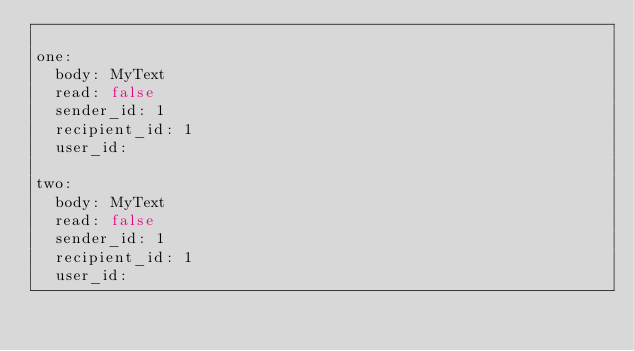Convert code to text. <code><loc_0><loc_0><loc_500><loc_500><_YAML_>
one:
  body: MyText
  read: false
  sender_id: 1
  recipient_id: 1
  user_id: 

two:
  body: MyText
  read: false
  sender_id: 1
  recipient_id: 1
  user_id: 
</code> 